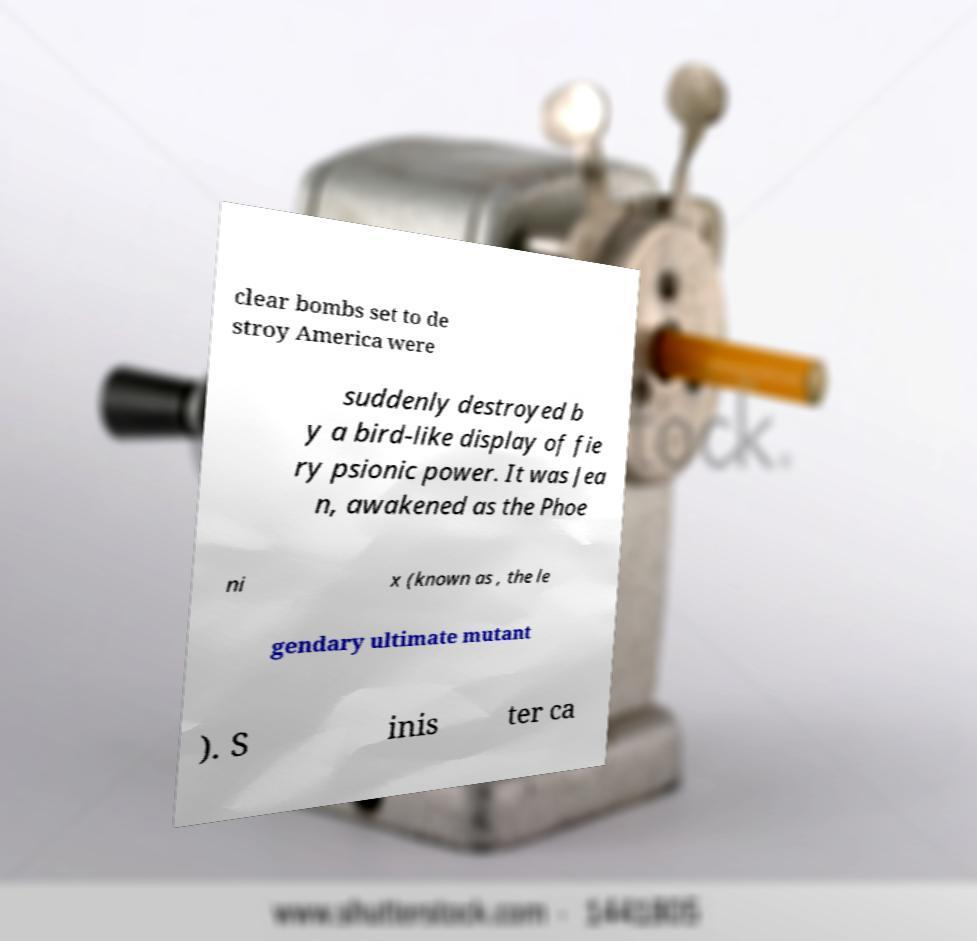I need the written content from this picture converted into text. Can you do that? clear bombs set to de stroy America were suddenly destroyed b y a bird-like display of fie ry psionic power. It was Jea n, awakened as the Phoe ni x (known as , the le gendary ultimate mutant ). S inis ter ca 